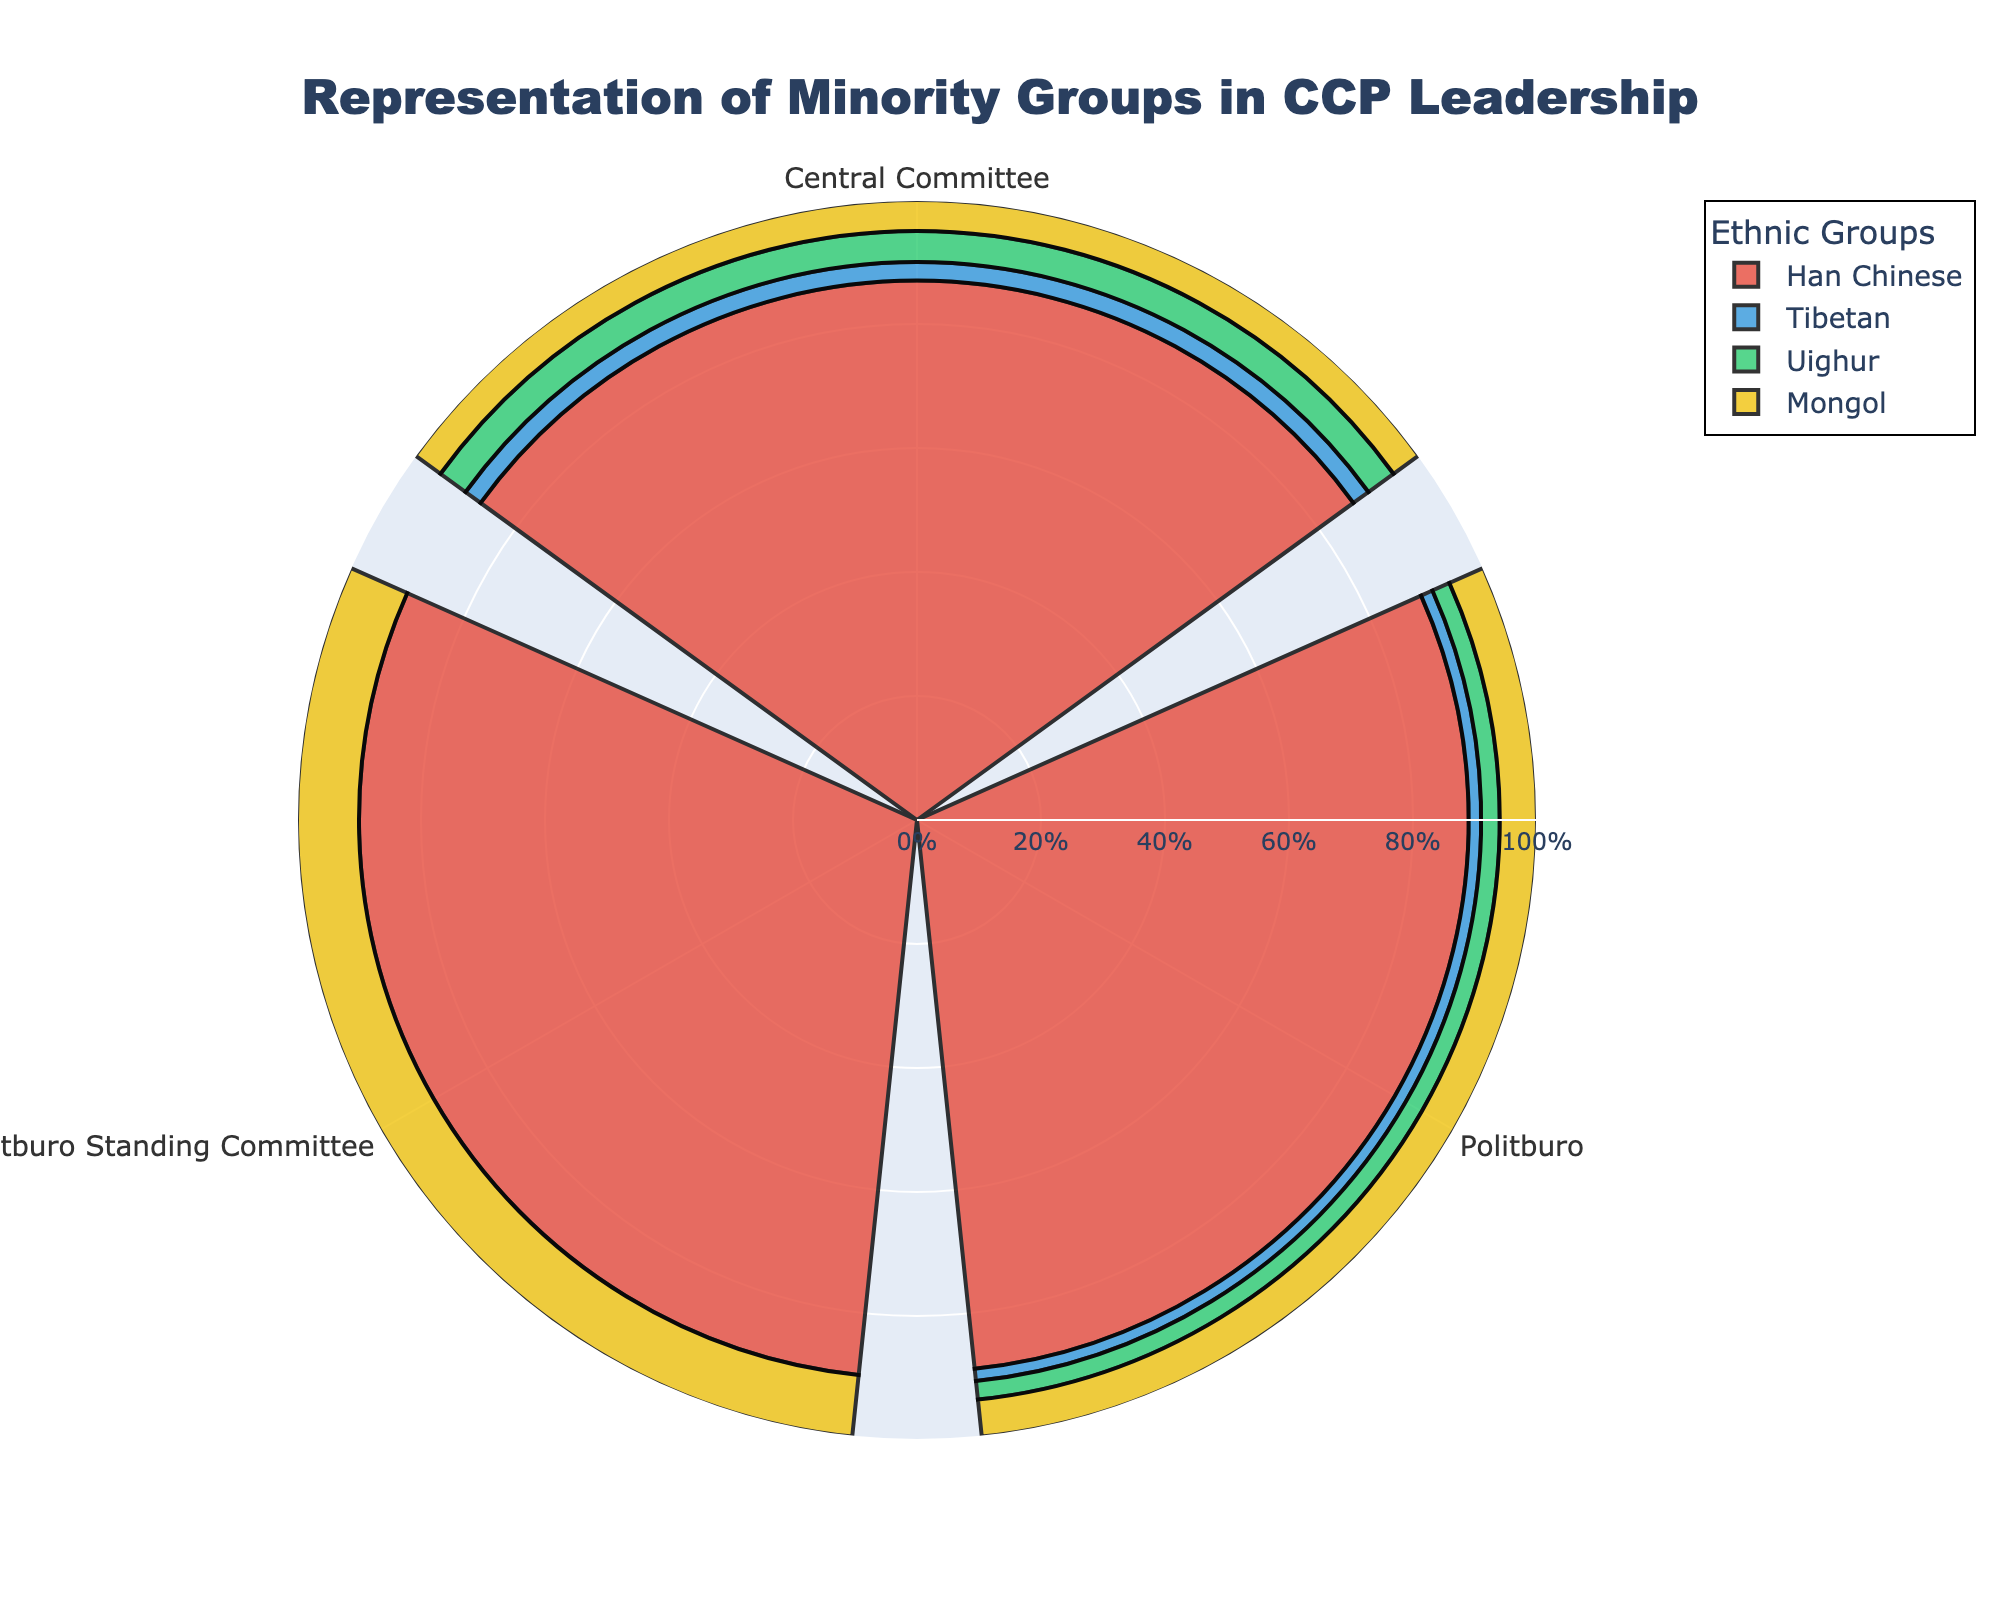Which group has the highest percentage representation in the Politburo Standing Committee? The highest percentage representation in the Politburo Standing Committee can be identified by looking at the longest bar within this group. Han Chinese have the longest bar at 90%.
Answer: Han Chinese What is the representation difference between Mongols in the Central Committee and in the Politburo? The percentages for Mongols in the Central Committee and in the Politburo are 5% and 6%, respectively. The representation difference is calculated by subtracting the smaller percentage from the larger percentage: 6% - 5% = 1%.
Answer: 1% Which ethnic group has zero representation in the Politburo Standing Committee and appears in other committees? To identify the ethnic groups with zero representation in the Politburo Standing Committee, look at the bars that are missing for the Politburo Standing Committee. Both Tibetan and Uighur have zero representation there and show up in other committees.
Answer: Tibetan, Uighur How does the representation of Uighurs in the Central Committee compare to their representation in the Politburo? Compare the lengths of the bars for Uighurs in the Central Committee (5%) and the Politburo (3%). The Uighur representation in the Central Committee is higher than in the Politburo.
Answer: Central Committee What is the combined percentage representation of minority groups (Tibetan, Uighur, Mongol) in the Central Committee? To find the combined percentage representation of minority groups in the Central Committee, sum the percentages for Tibetans (3%), Uighurs (5%), and Mongols (5%): 3% + 5% + 5% = 13%.
Answer: 13% How does the representation of Han Chinese in the Politburo compare to the overall representation of minority groups in the same position? The percentage of Han Chinese in the Politburo is 89%. The combined percentage of minority groups in the Politburo is the sum of Tibetans (2%), Uighurs (3%), and Mongols (6%): 2% + 3% + 6% = 11%. The Han Chinese representation is much higher.
Answer: Higher 